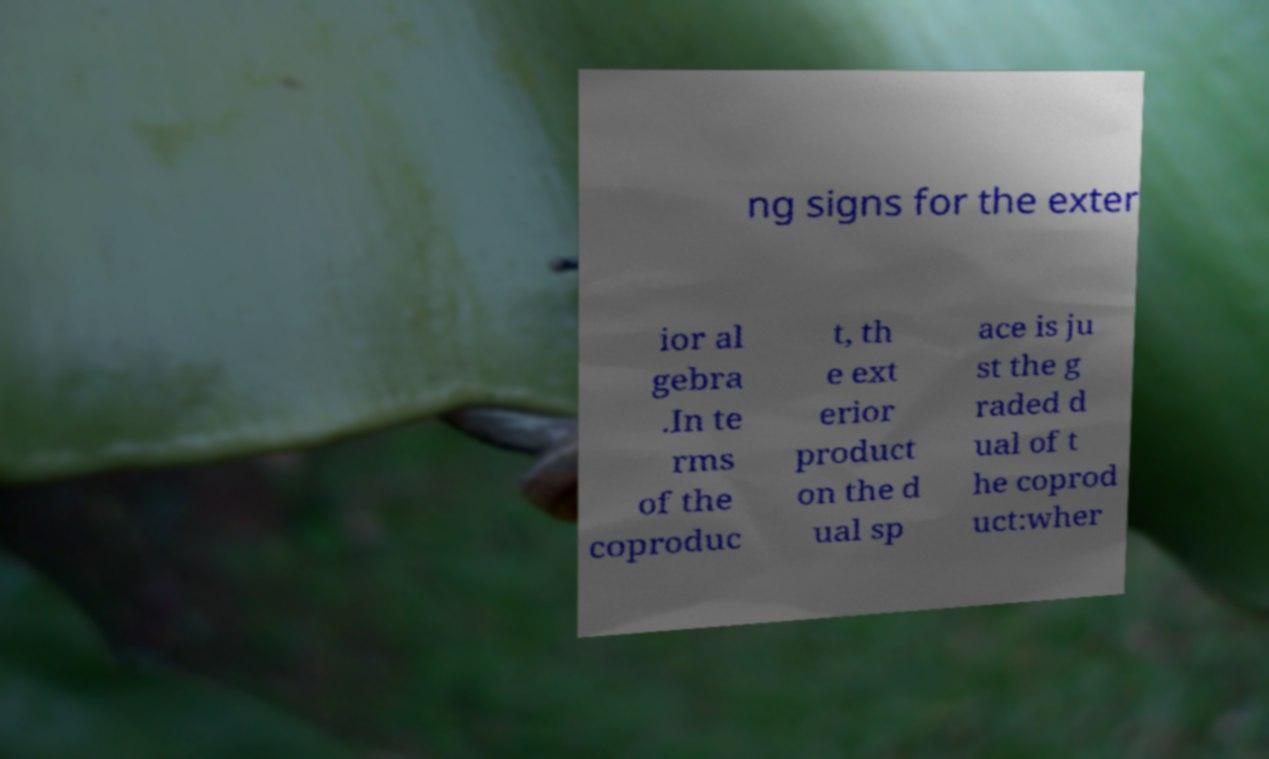Could you extract and type out the text from this image? ng signs for the exter ior al gebra .In te rms of the coproduc t, th e ext erior product on the d ual sp ace is ju st the g raded d ual of t he coprod uct:wher 